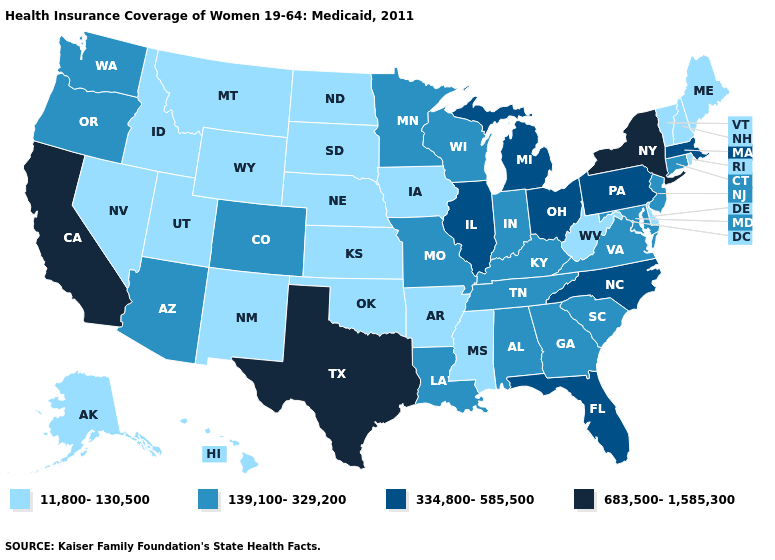Which states have the highest value in the USA?
Be succinct. California, New York, Texas. Does Colorado have the lowest value in the USA?
Write a very short answer. No. Among the states that border Iowa , which have the highest value?
Keep it brief. Illinois. Name the states that have a value in the range 11,800-130,500?
Answer briefly. Alaska, Arkansas, Delaware, Hawaii, Idaho, Iowa, Kansas, Maine, Mississippi, Montana, Nebraska, Nevada, New Hampshire, New Mexico, North Dakota, Oklahoma, Rhode Island, South Dakota, Utah, Vermont, West Virginia, Wyoming. Name the states that have a value in the range 334,800-585,500?
Concise answer only. Florida, Illinois, Massachusetts, Michigan, North Carolina, Ohio, Pennsylvania. What is the lowest value in the USA?
Short answer required. 11,800-130,500. Among the states that border Nevada , does California have the highest value?
Answer briefly. Yes. What is the value of Nevada?
Concise answer only. 11,800-130,500. Does Connecticut have the lowest value in the USA?
Write a very short answer. No. Name the states that have a value in the range 11,800-130,500?
Be succinct. Alaska, Arkansas, Delaware, Hawaii, Idaho, Iowa, Kansas, Maine, Mississippi, Montana, Nebraska, Nevada, New Hampshire, New Mexico, North Dakota, Oklahoma, Rhode Island, South Dakota, Utah, Vermont, West Virginia, Wyoming. What is the value of South Carolina?
Write a very short answer. 139,100-329,200. What is the highest value in the West ?
Concise answer only. 683,500-1,585,300. Name the states that have a value in the range 11,800-130,500?
Give a very brief answer. Alaska, Arkansas, Delaware, Hawaii, Idaho, Iowa, Kansas, Maine, Mississippi, Montana, Nebraska, Nevada, New Hampshire, New Mexico, North Dakota, Oklahoma, Rhode Island, South Dakota, Utah, Vermont, West Virginia, Wyoming. Which states hav the highest value in the Northeast?
Be succinct. New York. What is the value of Ohio?
Be succinct. 334,800-585,500. 